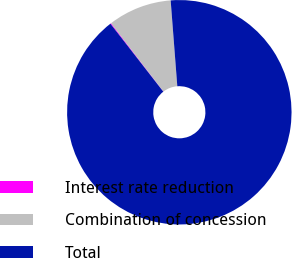<chart> <loc_0><loc_0><loc_500><loc_500><pie_chart><fcel>Interest rate reduction<fcel>Combination of concession<fcel>Total<nl><fcel>0.12%<fcel>9.18%<fcel>90.7%<nl></chart> 